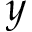<formula> <loc_0><loc_0><loc_500><loc_500>y</formula> 